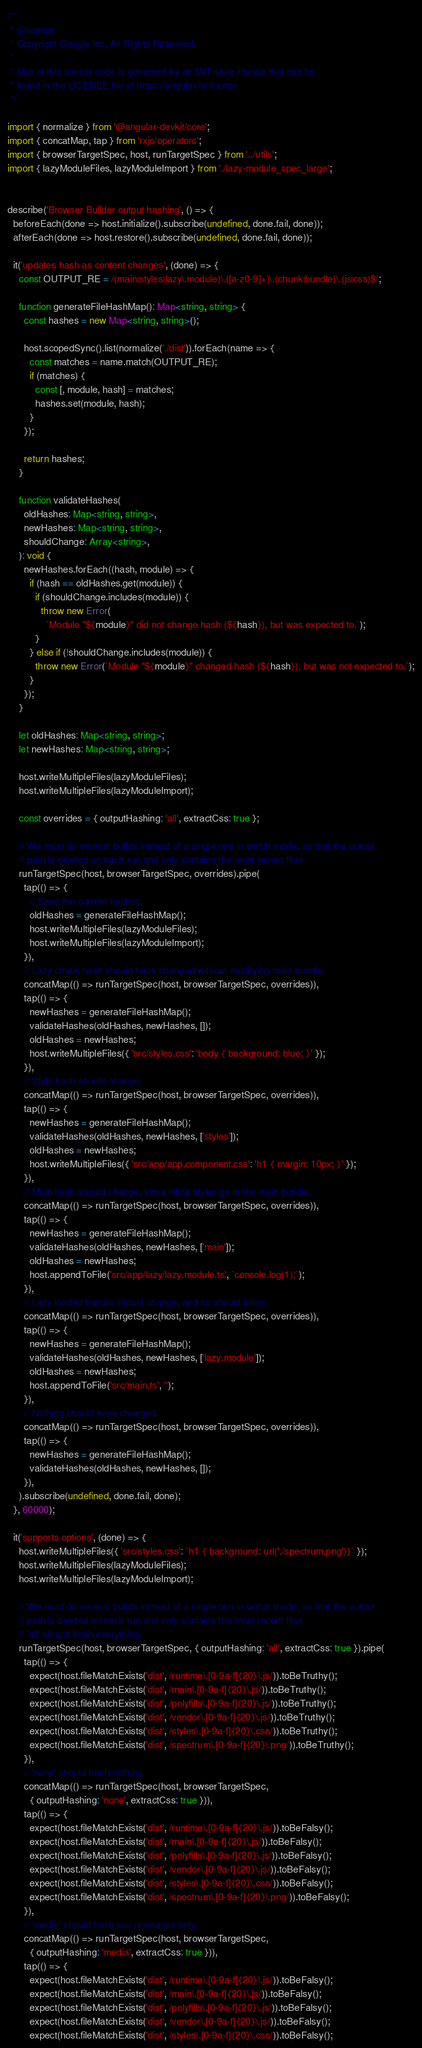<code> <loc_0><loc_0><loc_500><loc_500><_TypeScript_>/**
 * @license
 * Copyright Google Inc. All Rights Reserved.
 *
 * Use of this source code is governed by an MIT-style license that can be
 * found in the LICENSE file at https://angular.io/license
 */

import { normalize } from '@angular-devkit/core';
import { concatMap, tap } from 'rxjs/operators';
import { browserTargetSpec, host, runTargetSpec } from '../utils';
import { lazyModuleFiles, lazyModuleImport } from './lazy-module_spec_large';


describe('Browser Builder output hashing', () => {
  beforeEach(done => host.initialize().subscribe(undefined, done.fail, done));
  afterEach(done => host.restore().subscribe(undefined, done.fail, done));

  it('updates hash as content changes', (done) => {
    const OUTPUT_RE = /(main|styles|lazy\.module)\.([a-z0-9]+)\.(chunk|bundle)\.(js|css)$/;

    function generateFileHashMap(): Map<string, string> {
      const hashes = new Map<string, string>();

      host.scopedSync().list(normalize('./dist')).forEach(name => {
        const matches = name.match(OUTPUT_RE);
        if (matches) {
          const [, module, hash] = matches;
          hashes.set(module, hash);
        }
      });

      return hashes;
    }

    function validateHashes(
      oldHashes: Map<string, string>,
      newHashes: Map<string, string>,
      shouldChange: Array<string>,
    ): void {
      newHashes.forEach((hash, module) => {
        if (hash == oldHashes.get(module)) {
          if (shouldChange.includes(module)) {
            throw new Error(
              `Module "${module}" did not change hash (${hash}), but was expected to.`);
          }
        } else if (!shouldChange.includes(module)) {
          throw new Error(`Module "${module}" changed hash (${hash}), but was not expected to.`);
        }
      });
    }

    let oldHashes: Map<string, string>;
    let newHashes: Map<string, string>;

    host.writeMultipleFiles(lazyModuleFiles);
    host.writeMultipleFiles(lazyModuleImport);

    const overrides = { outputHashing: 'all', extractCss: true };

    // We must do several builds instead of a single one in watch mode, so that the output
    // path is deleted on each run and only contains the most recent files.
    runTargetSpec(host, browserTargetSpec, overrides).pipe(
      tap(() => {
        // Save the current hashes.
        oldHashes = generateFileHashMap();
        host.writeMultipleFiles(lazyModuleFiles);
        host.writeMultipleFiles(lazyModuleImport);
      }),
      // Lazy chunk hash should have changed without modifying main bundle.
      concatMap(() => runTargetSpec(host, browserTargetSpec, overrides)),
      tap(() => {
        newHashes = generateFileHashMap();
        validateHashes(oldHashes, newHashes, []);
        oldHashes = newHashes;
        host.writeMultipleFiles({ 'src/styles.css': 'body { background: blue; }' });
      }),
      // Style hash should change.
      concatMap(() => runTargetSpec(host, browserTargetSpec, overrides)),
      tap(() => {
        newHashes = generateFileHashMap();
        validateHashes(oldHashes, newHashes, ['styles']);
        oldHashes = newHashes;
        host.writeMultipleFiles({ 'src/app/app.component.css': 'h1 { margin: 10px; }' });
      }),
      // Main hash should change, since inline styles go in the main bundle.
      concatMap(() => runTargetSpec(host, browserTargetSpec, overrides)),
      tap(() => {
        newHashes = generateFileHashMap();
        validateHashes(oldHashes, newHashes, ['main']);
        oldHashes = newHashes;
        host.appendToFile('src/app/lazy/lazy.module.ts', `console.log(1);`);
      }),
      // Lazy loaded bundle should change, and so should inline.
      concatMap(() => runTargetSpec(host, browserTargetSpec, overrides)),
      tap(() => {
        newHashes = generateFileHashMap();
        validateHashes(oldHashes, newHashes, ['lazy.module']);
        oldHashes = newHashes;
        host.appendToFile('src/main.ts', '');
      }),
      // Nothing should have changed.
      concatMap(() => runTargetSpec(host, browserTargetSpec, overrides)),
      tap(() => {
        newHashes = generateFileHashMap();
        validateHashes(oldHashes, newHashes, []);
      }),
    ).subscribe(undefined, done.fail, done);
  }, 60000);

  it('supports options', (done) => {
    host.writeMultipleFiles({ 'src/styles.css': `h1 { background: url('./spectrum.png')}` });
    host.writeMultipleFiles(lazyModuleFiles);
    host.writeMultipleFiles(lazyModuleImport);

    // We must do several builds instead of a single one in watch mode, so that the output
    // path is deleted on each run and only contains the most recent files.
    // 'all' should hash everything.
    runTargetSpec(host, browserTargetSpec, { outputHashing: 'all', extractCss: true }).pipe(
      tap(() => {
        expect(host.fileMatchExists('dist', /runtime\.[0-9a-f]{20}\.js/)).toBeTruthy();
        expect(host.fileMatchExists('dist', /main\.[0-9a-f]{20}\.js/)).toBeTruthy();
        expect(host.fileMatchExists('dist', /polyfills\.[0-9a-f]{20}\.js/)).toBeTruthy();
        expect(host.fileMatchExists('dist', /vendor\.[0-9a-f]{20}\.js/)).toBeTruthy();
        expect(host.fileMatchExists('dist', /styles\.[0-9a-f]{20}\.css/)).toBeTruthy();
        expect(host.fileMatchExists('dist', /spectrum\.[0-9a-f]{20}\.png/)).toBeTruthy();
      }),
      // 'none' should hash nothing.
      concatMap(() => runTargetSpec(host, browserTargetSpec,
        { outputHashing: 'none', extractCss: true })),
      tap(() => {
        expect(host.fileMatchExists('dist', /runtime\.[0-9a-f]{20}\.js/)).toBeFalsy();
        expect(host.fileMatchExists('dist', /main\.[0-9a-f]{20}\.js/)).toBeFalsy();
        expect(host.fileMatchExists('dist', /polyfills\.[0-9a-f]{20}\.js/)).toBeFalsy();
        expect(host.fileMatchExists('dist', /vendor\.[0-9a-f]{20}\.js/)).toBeFalsy();
        expect(host.fileMatchExists('dist', /styles\.[0-9a-f]{20}\.css/)).toBeFalsy();
        expect(host.fileMatchExists('dist', /spectrum\.[0-9a-f]{20}\.png/)).toBeFalsy();
      }),
      // 'media' should hash css resources only.
      concatMap(() => runTargetSpec(host, browserTargetSpec,
        { outputHashing: 'media', extractCss: true })),
      tap(() => {
        expect(host.fileMatchExists('dist', /runtime\.[0-9a-f]{20}\.js/)).toBeFalsy();
        expect(host.fileMatchExists('dist', /main\.[0-9a-f]{20}\.js/)).toBeFalsy();
        expect(host.fileMatchExists('dist', /polyfills\.[0-9a-f]{20}\.js/)).toBeFalsy();
        expect(host.fileMatchExists('dist', /vendor\.[0-9a-f]{20}\.js/)).toBeFalsy();
        expect(host.fileMatchExists('dist', /styles\.[0-9a-f]{20}\.css/)).toBeFalsy();</code> 